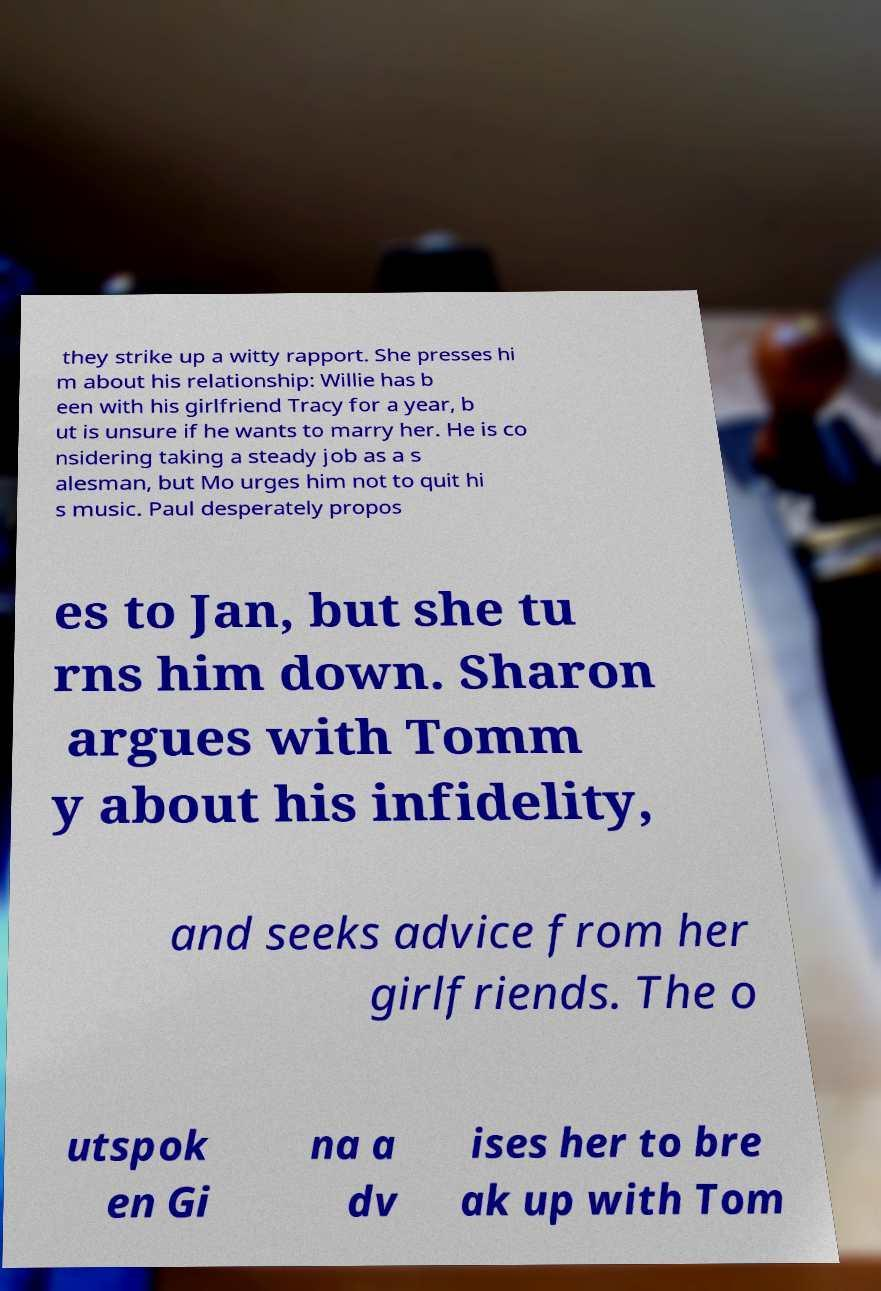There's text embedded in this image that I need extracted. Can you transcribe it verbatim? they strike up a witty rapport. She presses hi m about his relationship: Willie has b een with his girlfriend Tracy for a year, b ut is unsure if he wants to marry her. He is co nsidering taking a steady job as a s alesman, but Mo urges him not to quit hi s music. Paul desperately propos es to Jan, but she tu rns him down. Sharon argues with Tomm y about his infidelity, and seeks advice from her girlfriends. The o utspok en Gi na a dv ises her to bre ak up with Tom 